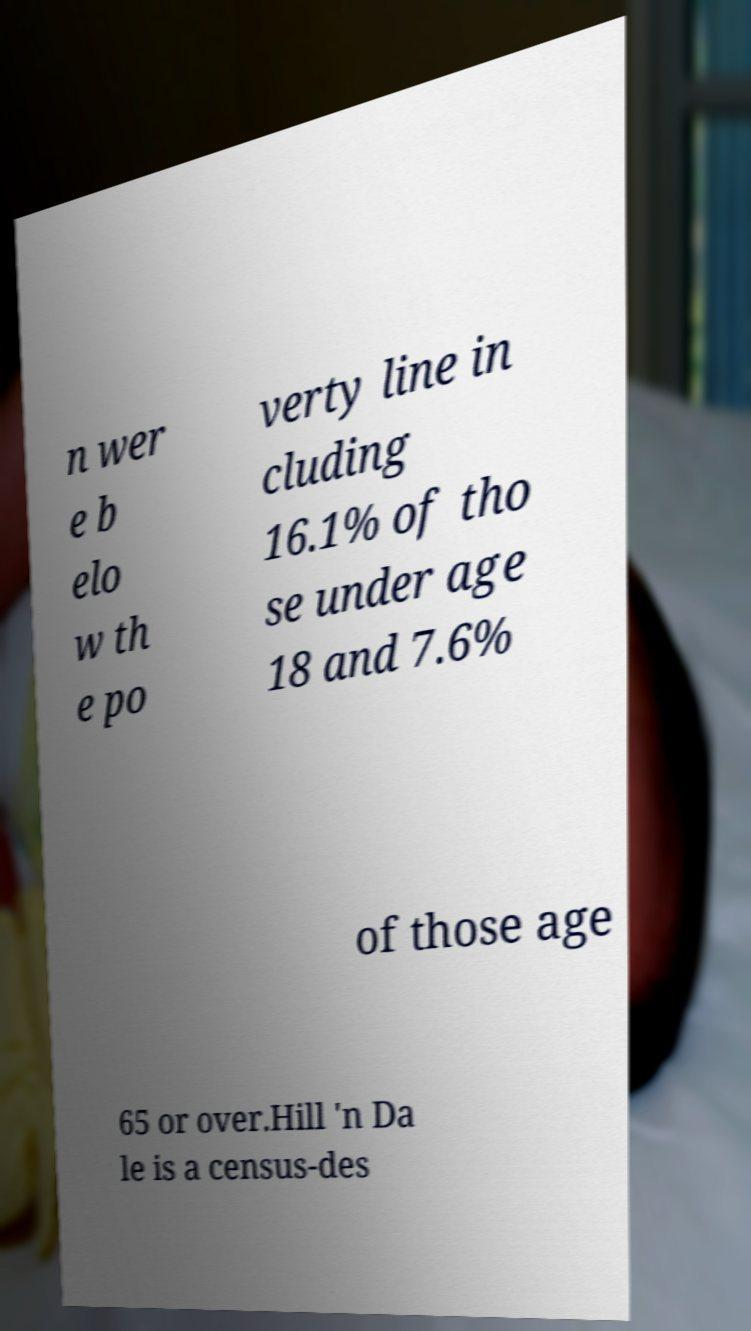Please read and relay the text visible in this image. What does it say? n wer e b elo w th e po verty line in cluding 16.1% of tho se under age 18 and 7.6% of those age 65 or over.Hill 'n Da le is a census-des 